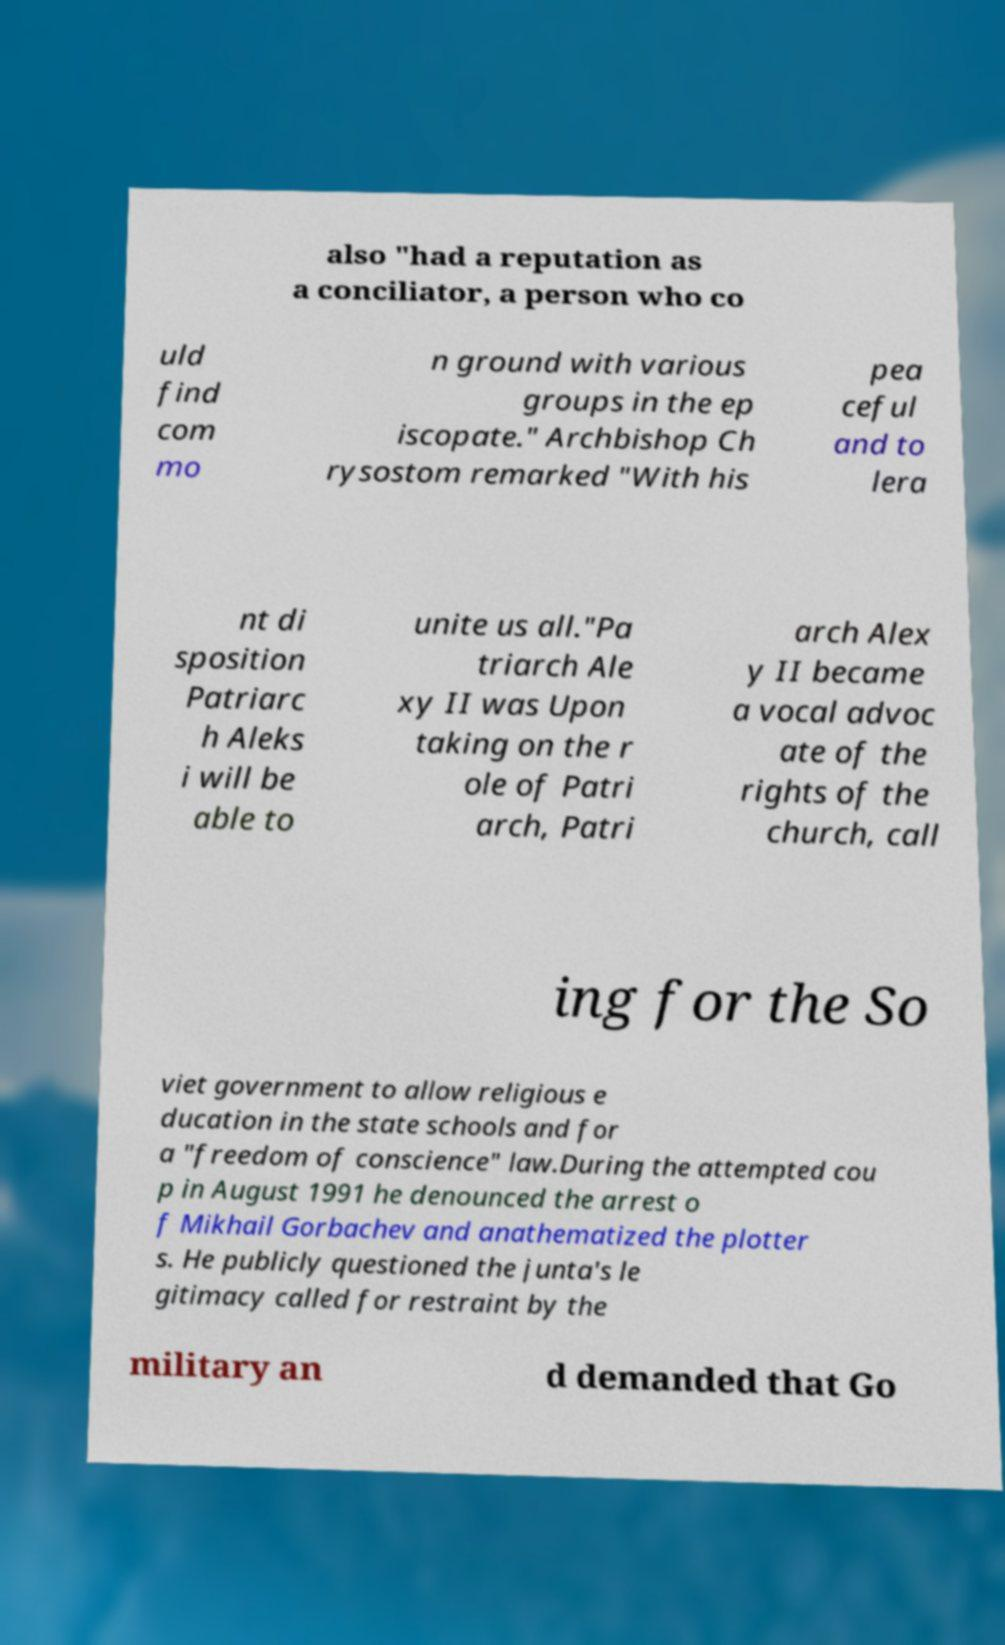Please identify and transcribe the text found in this image. also "had a reputation as a conciliator, a person who co uld find com mo n ground with various groups in the ep iscopate." Archbishop Ch rysostom remarked "With his pea ceful and to lera nt di sposition Patriarc h Aleks i will be able to unite us all."Pa triarch Ale xy II was Upon taking on the r ole of Patri arch, Patri arch Alex y II became a vocal advoc ate of the rights of the church, call ing for the So viet government to allow religious e ducation in the state schools and for a "freedom of conscience" law.During the attempted cou p in August 1991 he denounced the arrest o f Mikhail Gorbachev and anathematized the plotter s. He publicly questioned the junta's le gitimacy called for restraint by the military an d demanded that Go 